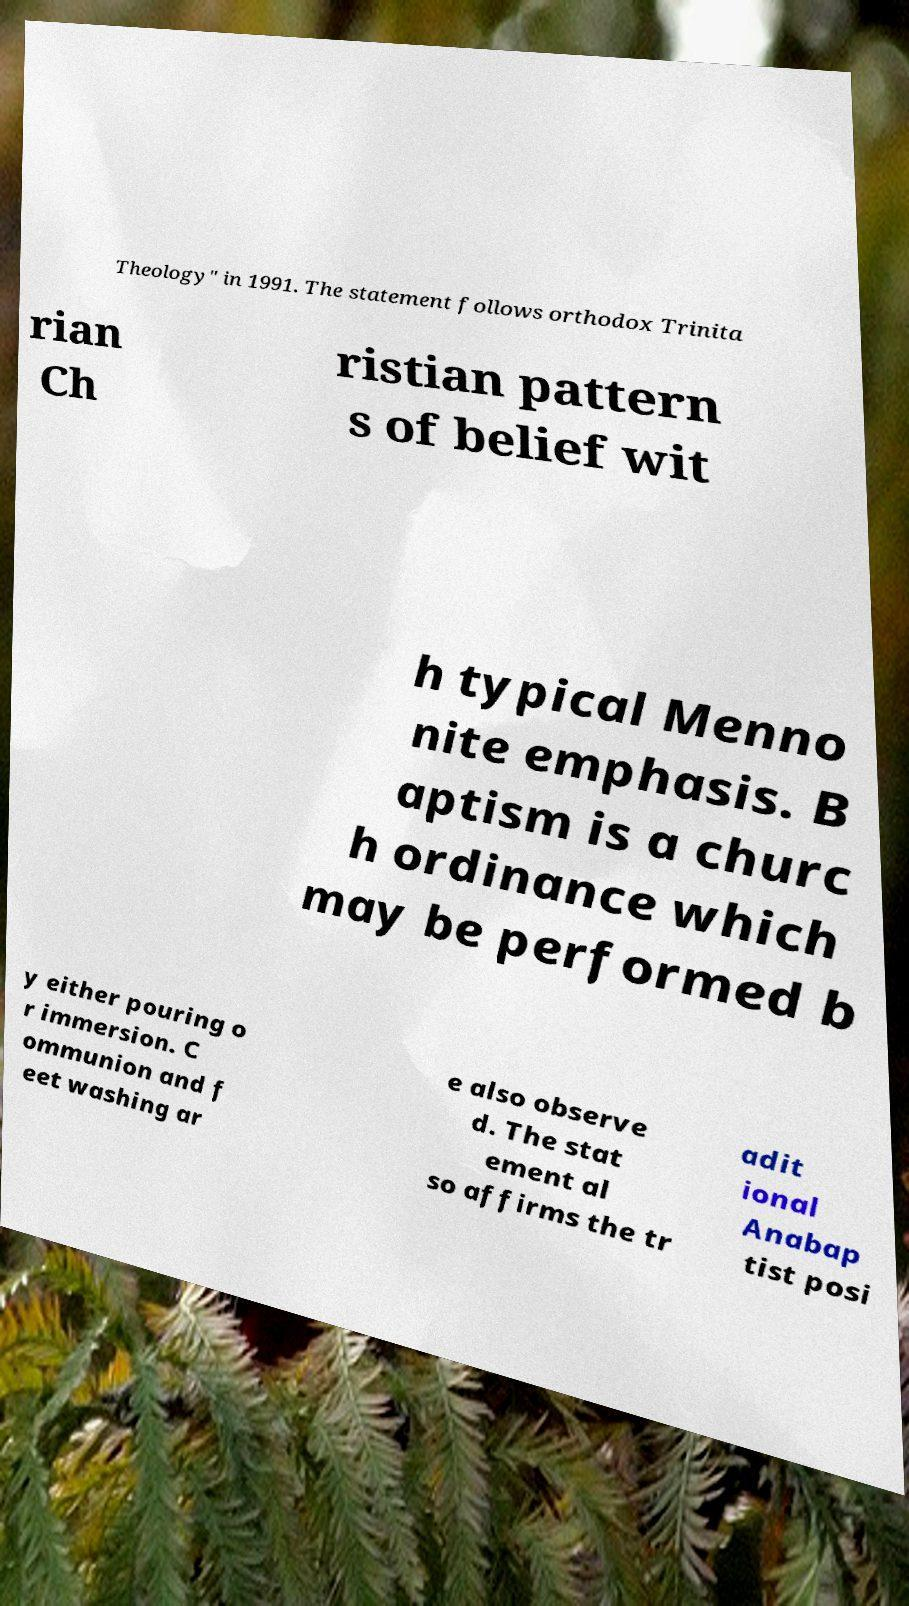Can you read and provide the text displayed in the image?This photo seems to have some interesting text. Can you extract and type it out for me? Theology" in 1991. The statement follows orthodox Trinita rian Ch ristian pattern s of belief wit h typical Menno nite emphasis. B aptism is a churc h ordinance which may be performed b y either pouring o r immersion. C ommunion and f eet washing ar e also observe d. The stat ement al so affirms the tr adit ional Anabap tist posi 